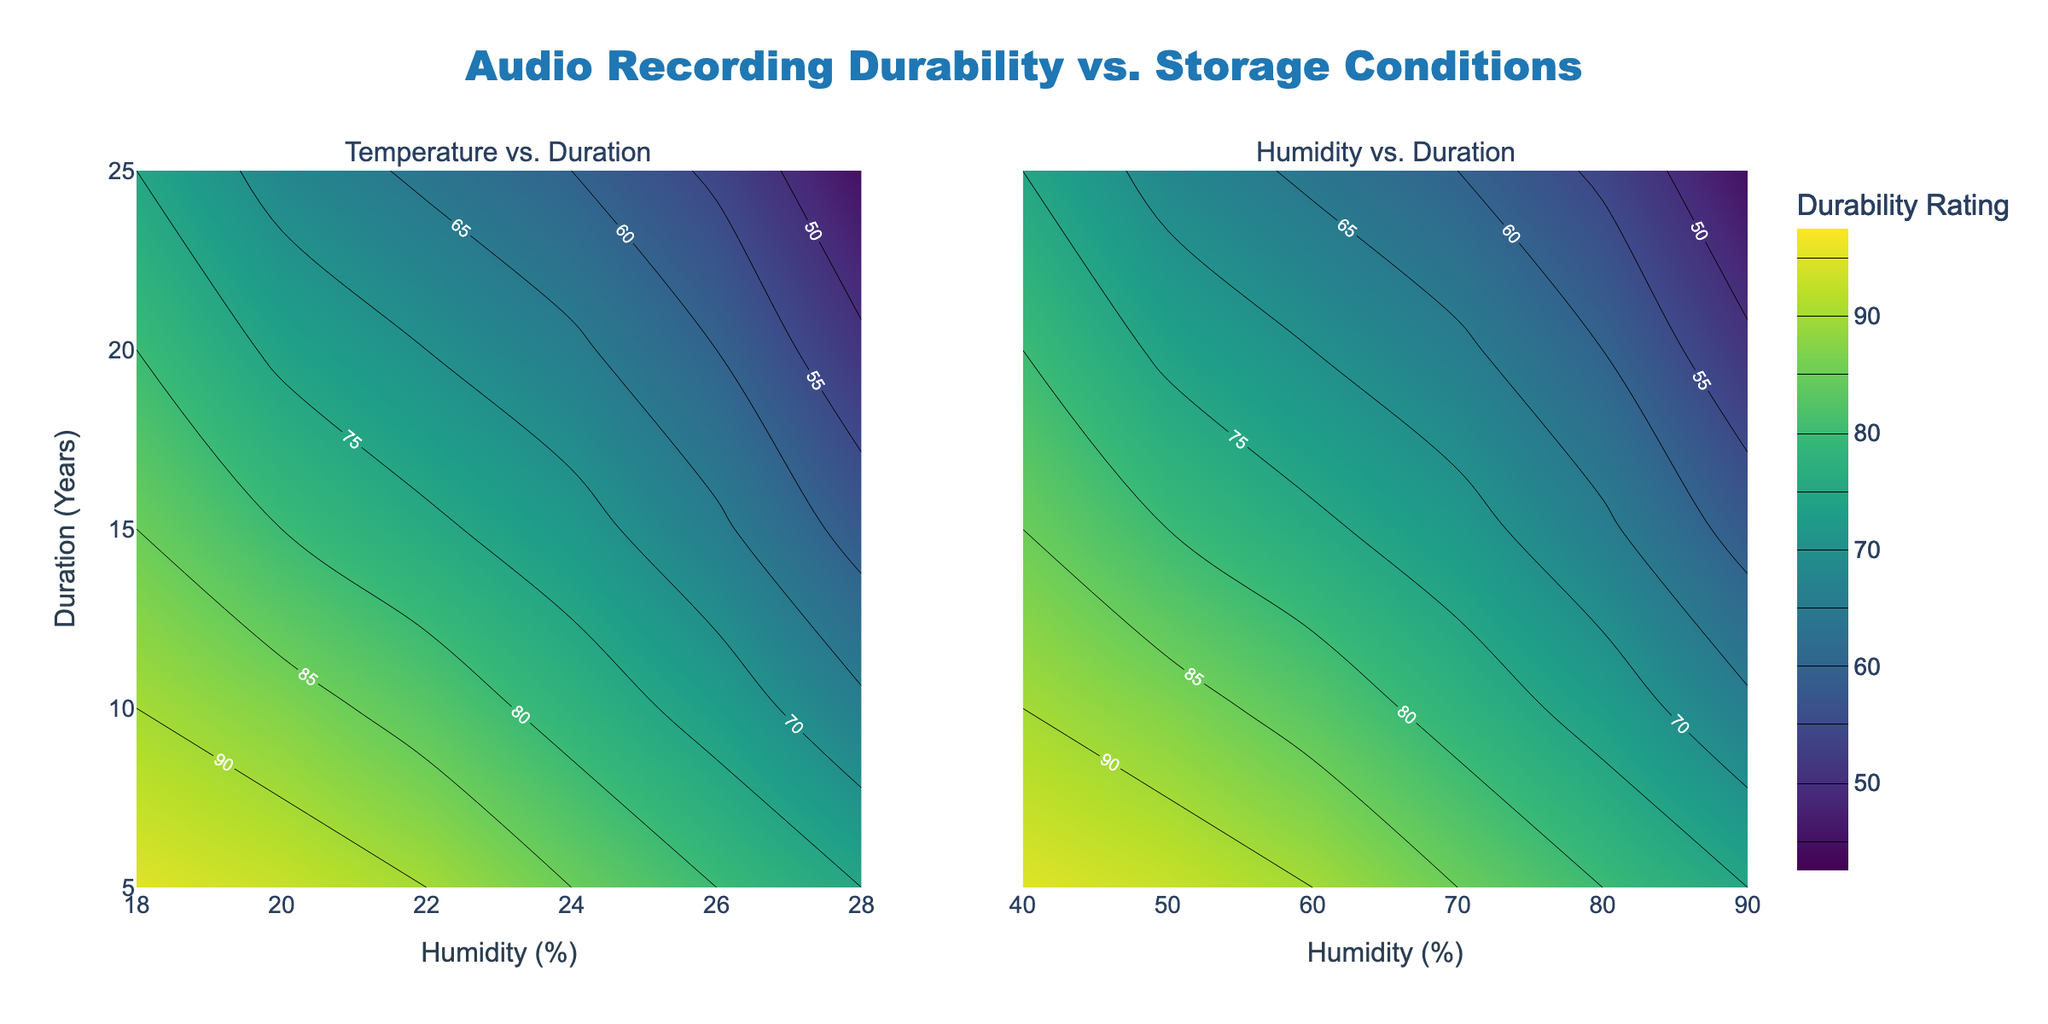What is the title of the figure? The title of the figure is placed at the top center of the plot and clearly states the main focus of the visualization.
Answer: Audio Recording Durability vs. Storage Conditions What are the x-axis labels for both subplots? The x-axis labels for both subplots indicate the variables being compared against Duration (Years). The left subplot shows "Temperature (C)" and the right subplot shows "Humidity (%)".
Answer: Temperature (C) and Humidity (%) Which subplot reveals the relationship between Humidity (%) and Duration (Years)? The right subplot illustrates the relationship between Humidity (%) and Duration (Years) according to the axis labels.
Answer: The right subplot What is the durability rating when the temperature is 18°C and the duration is 10 years? In the left subplot, find the contour line corresponding to 18°C on the x-axis and 10 years on the y-axis. The plot shows a specific value on the contour line labeled with the durability rating.
Answer: 90 How does durability rating change with increasing temperature at a fixed duration of 5 years? In the left subplot, follow the contour line at a duration of 5 years. As temperature increases from 18°C to 28°C, observe how the durability rating values change along this line.
Answer: It decreases How do the durability ratings compare for a 10-year duration at 50% humidity and 70% humidity? In the right subplot, locate the 10-year line. Compare the durability ratings corresponding to 50% humidity and 70% humidity on this line.
Answer: 73 at 50% and 78 at 70% What is the overall trend in durability ratings as the duration increases from 5 to 25 years for most storage conditions? In both subplots, observe the contour lines as the y-axis (duration) increases. Notice how the durability ratings consistently change with increased duration across different temperatures and humidities.
Answer: It decreases Which temperature and humidity combination seems to maintain the highest durability rating over 20 years? Identify the intersection where 20 years line meets the contour line with the highest durability rating across both subplots.
Answer: 18°C, 40% Is there a scenario where the durability rating is below 50? Check both subplots for any contour lines with a label below 50 and identify the corresponding conditions (temperature and humidity).
Answer: Yes, at 28°C or 90% humidity for 25 years What are the color representations indicating the highest and lowest durability ratings on the contour plots? Observe the color legend provided on the right of the plot indicating ranges of durability ratings. Identify the colors corresponding to the highest and lowest values.
Answer: Dark green (highest) and dark yellow/light brown (lowest) 